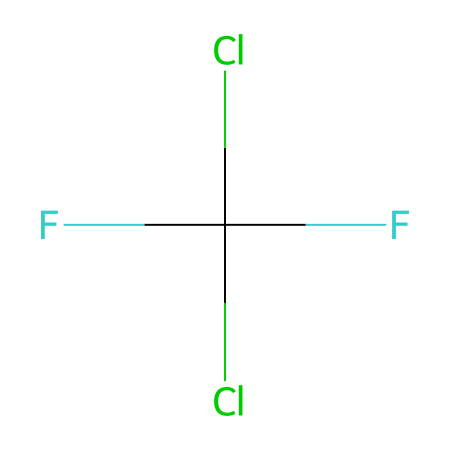What is the chemical name of this refrigerant? The SMILES representation can be deciphered to identify the chemical components and structure. Given that it contains chlorine, fluorine, and a carbon backbone, it corresponds to the name chlorodifluoromethane.
Answer: chlorodifluoromethane How many chlorine atoms are present in the structure? By analyzing the SMILES notation, specifically looking for "Cl", we see that two chlorine atoms are indicated.
Answer: 2 What is the total number of carbon atoms in R-22? The SMILES representation indicates there is one carbon atom in the structure (the central element in the notation).
Answer: 1 Which functional groups are present in R-22? The structure contains fluorine and chlorine atoms, which are characteristic of halogenated compounds, making those atoms the functional groups.
Answer: chlorofluorocarbon Is R-22 a saturated or unsaturated compound? The presence of only single bonds between the carbon and halogen atoms (as represented in the structure) indicates that R-22 is a saturated compound.
Answer: saturated What type of refrigerant is R-22 classified as? R-22 is categorized as a hydrochlorofluorocarbon refrigerant based on the chemical structure, which consists of hydrogen, chlorine, fluorine, and carbon.
Answer: hydrochlorofluorocarbon 